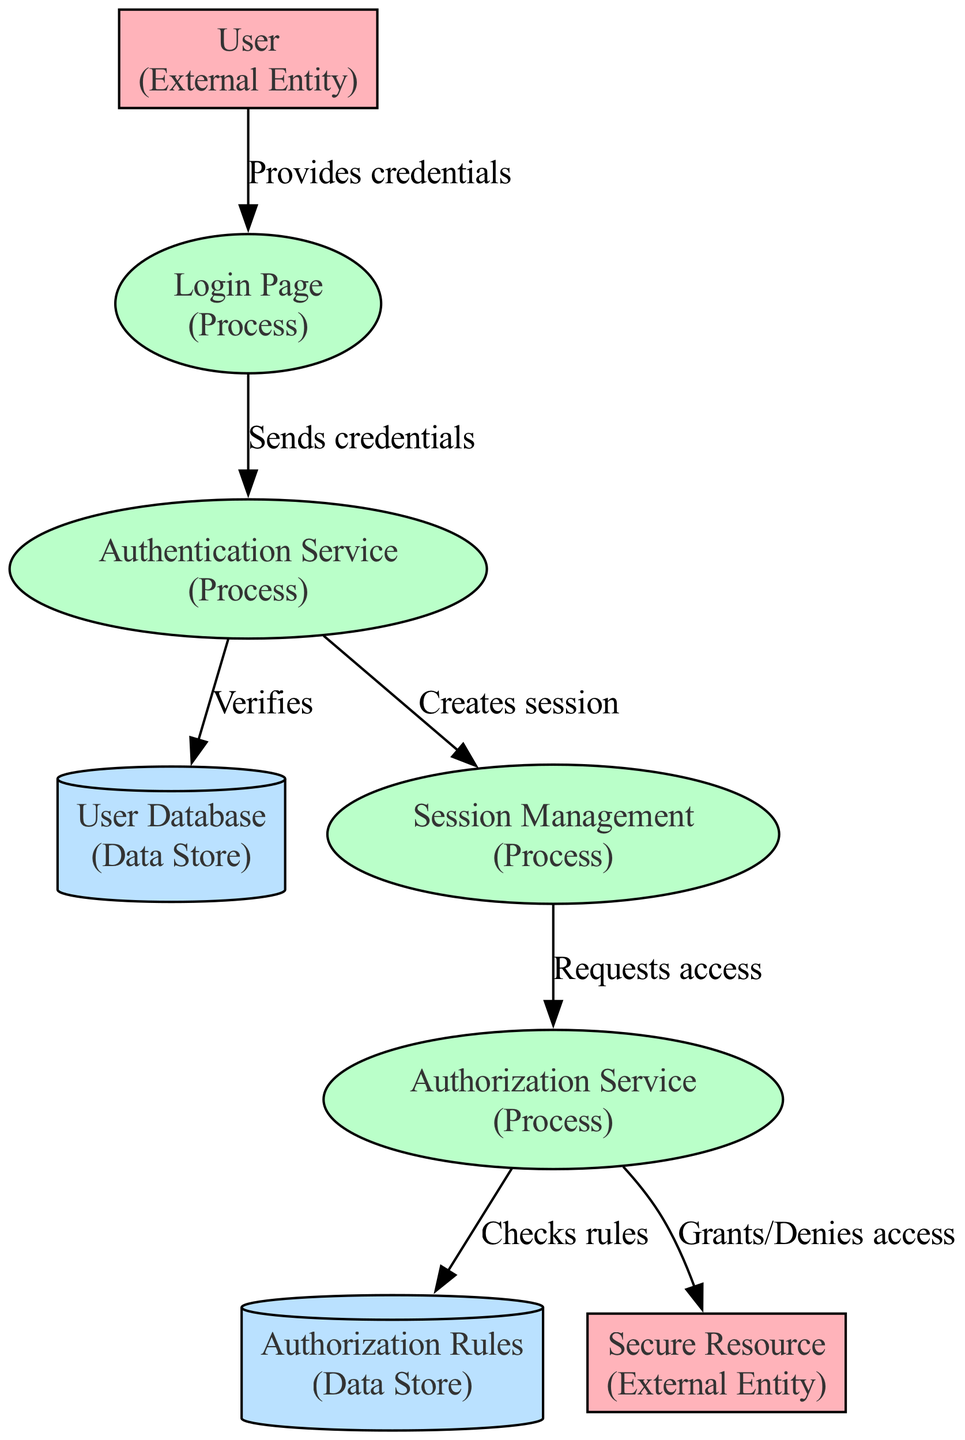What is the first process that the user interacts with? The diagram shows that the user interacts with the "Login Page" first before proceeding with authentication activities.
Answer: Login Page How many data stores are present in the diagram? By examining the diagram, we identify two data stores: "User Database" and "Authorization Rules." Hence, the total is counted.
Answer: 2 What does the "Authentication Service" send to the "Session Management"? In the diagram, it is specified that the "Authentication Service" creates a session, which corresponds to the action represented in the edge between these two processes.
Answer: Creates session What triggers the "Authorization Service" to request access? As per the diagram, the "Session Management" processes trigger the "Authorization Service" to request access, as indicated by the directional edge between these two processes.
Answer: Session Management Which external entity is trying to access the company's services? The diagram indicates that the "User" is the external entity that provides credentials in order to access services.
Answer: User What checks does the "Authorization Service" perform before granting access? The flow in the diagram indicates that the "Authorization Service" checks the rules stored in "Authorization Rules" before deciding to grant or deny access to resources.
Answer: Checks rules How does the user provide their credentials? The diagram depicts that the user provides their credentials to the "Login Page" which is the first interaction point in the authentication process shown.
Answer: Provides credentials What serves as the repository for user credentials? The diagram clearly shows that the "User Database" serves as the data store where user credentials and profile information are maintained.
Answer: User Database What happens after the "Authorization Service" verifies the rules? Following the verification of rules, the "Authorization Service" either grants or denies access to the "Secure Resource," illustrated in the flow of the diagram.
Answer: Grants/Denies access 